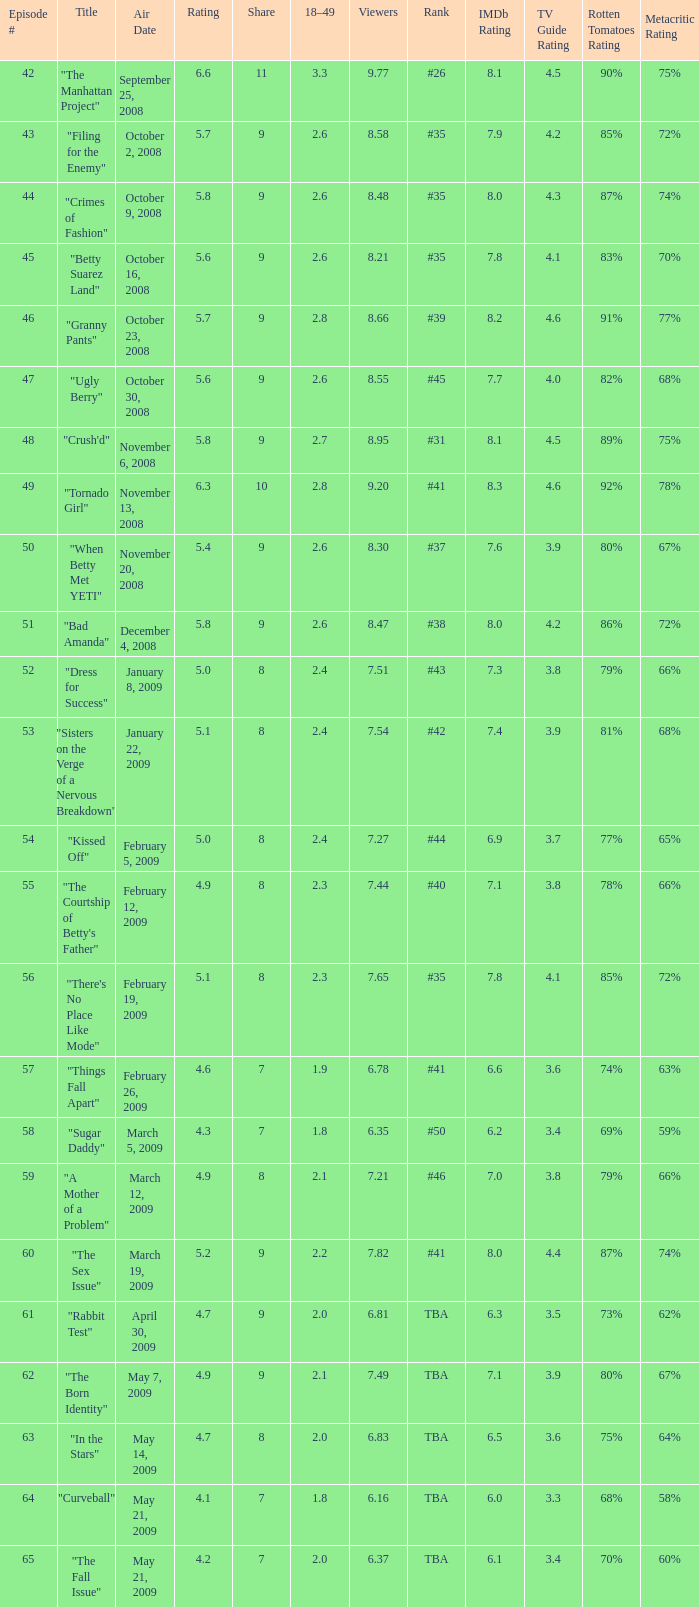For episodes with a 9 share and ranked 35 with less than 8.21 viewers, what is the average episode number? None. 